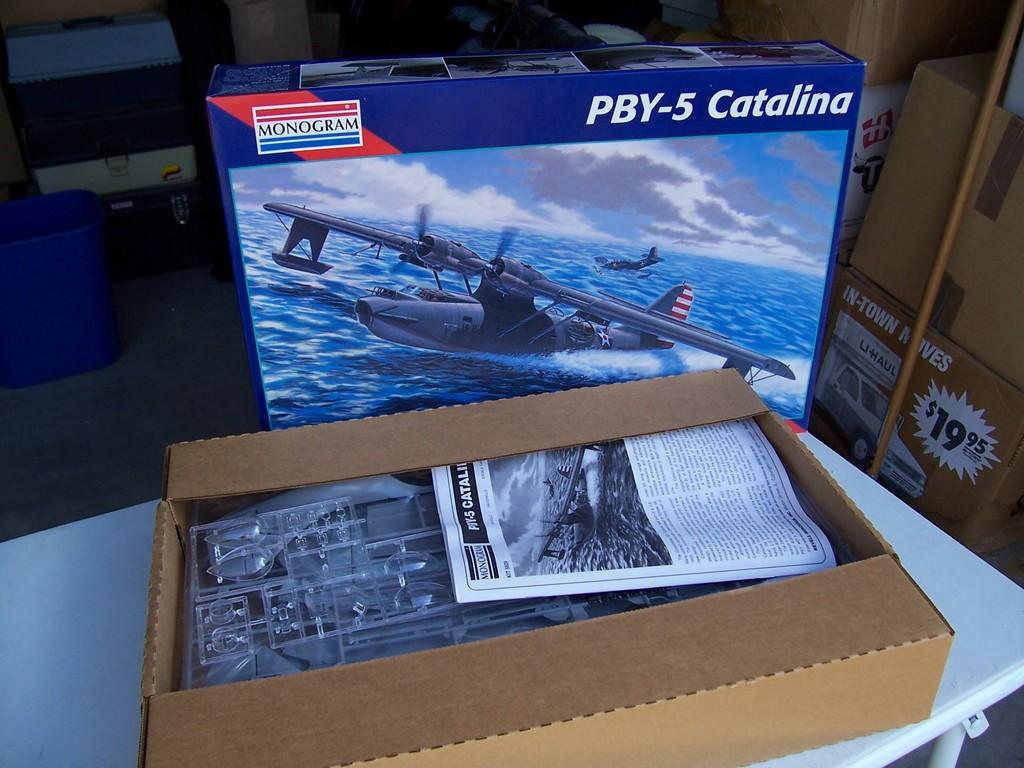<image>
Relay a brief, clear account of the picture shown. A model airplane set for a PBY-5 Catalina airplane 